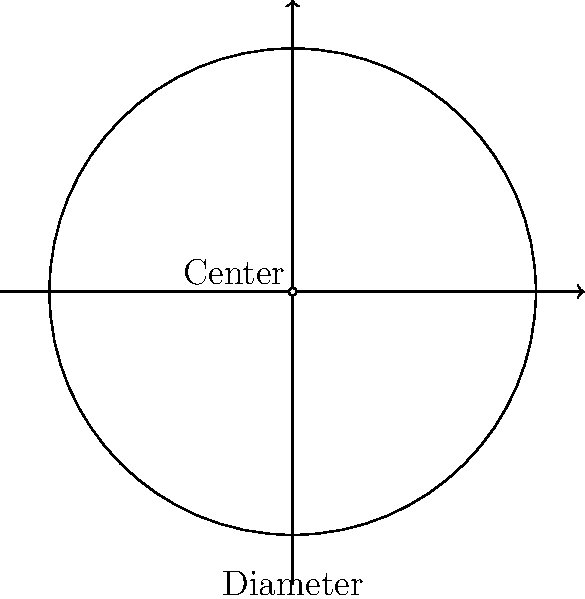In your latest expedition to study an indigenous village, you've come across a fascinating circular gathering space. The village elder, with a twinkle in her eye, challenges you to estimate the area of this space using only a long piece of string and your knowledge of pi. She tells you that the diameter of the circle is 20 meters. Channel your inner Indiana Jones and calculate the approximate area of this gathering space. Don't forget to show your work, or you might end up facing a giant boulder rolling your way! Let's break this down step-by-step, using our anthropological wit and pop culture savvy:

1) First, let's recall the formula for the area of a circle:
   $$A = \pi r^2$$
   Where $A$ is the area, $\pi$ is pi, and $r$ is the radius.

2) We're given the diameter, which is 20 meters. The radius is half of the diameter:
   $$r = \frac{diameter}{2} = \frac{20}{2} = 10\text{ meters}$$

3) Now, let's plug this into our formula:
   $$A = \pi (10)^2$$

4) Simplify:
   $$A = 100\pi\text{ square meters}$$

5) If we want to calculate this more precisely (although the village elder might be impressed with our pi knowledge already), we can use 3.14 as an approximation for pi:
   $$A \approx 100 * 3.14 = 314\text{ square meters}$$

Remember, as Indiana Jones would say, "It's not the years, honey, it's the mileage." In this case, it's not the exact number, but the method that counts!
Answer: $314\text{ m}^2$ 